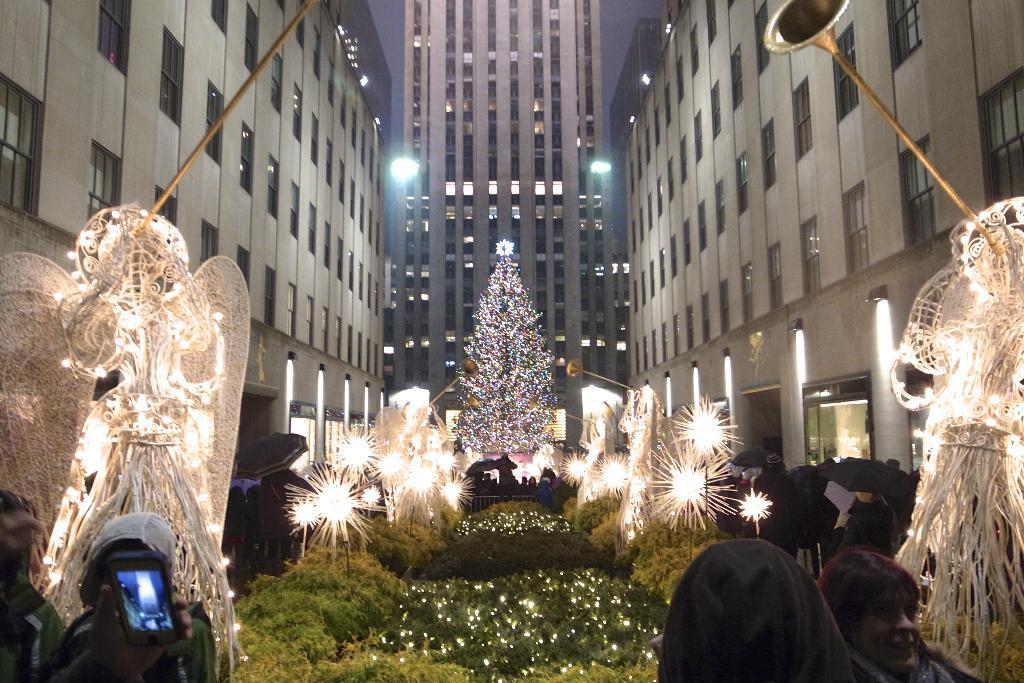How would you summarize this image in a sentence or two? In this image I can see the statues with lights. To the side of these statues I can see the group of people. I can see one person holding the mobile. To the side of these people I can see the plants, lights and the Christmas tree. In the background I can see the buildings and the sky. 